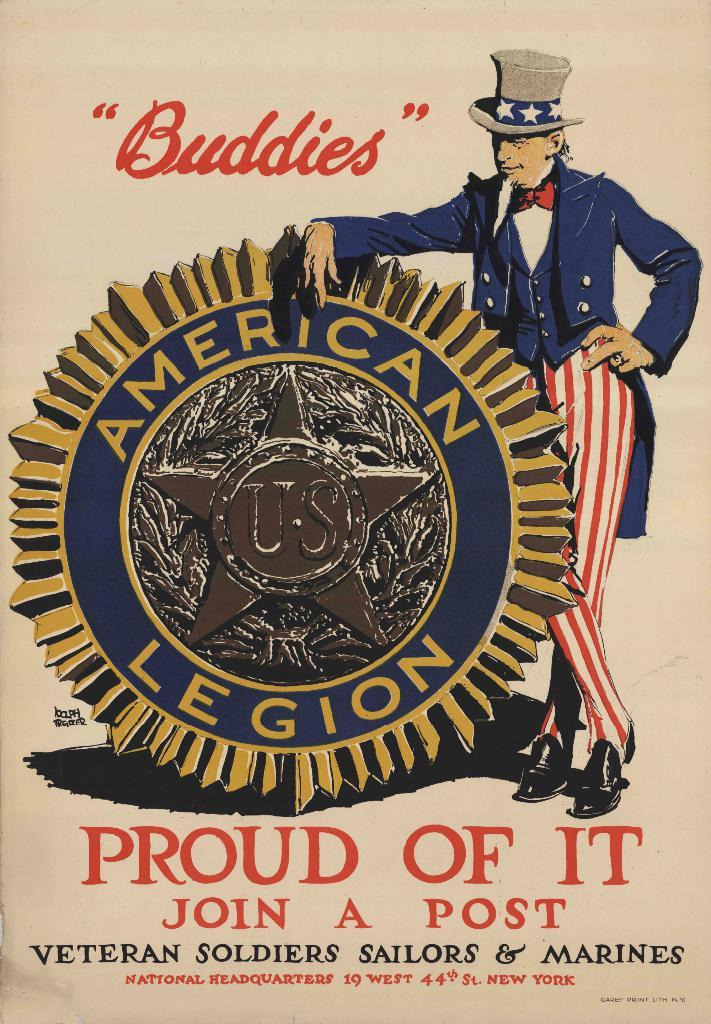What word is in quotes on the ad?
Provide a short and direct response. Buddies. What type of legion is it?
Your response must be concise. American. 